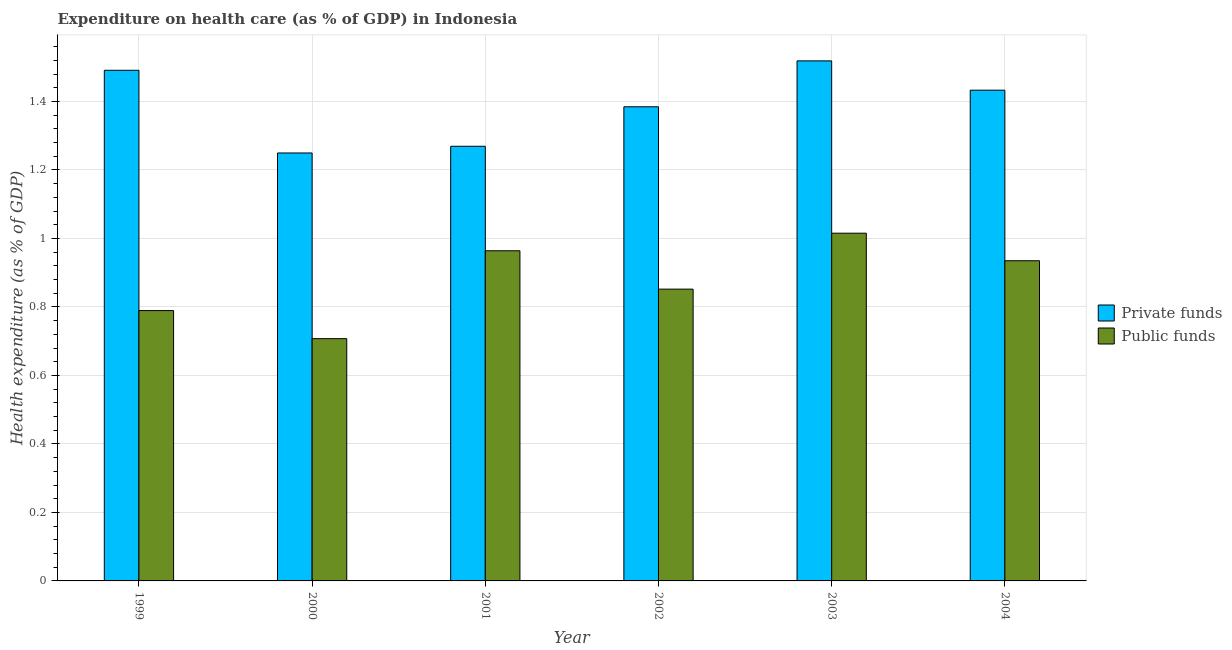How many different coloured bars are there?
Your response must be concise. 2. How many groups of bars are there?
Make the answer very short. 6. Are the number of bars per tick equal to the number of legend labels?
Make the answer very short. Yes. What is the label of the 6th group of bars from the left?
Provide a succinct answer. 2004. In how many cases, is the number of bars for a given year not equal to the number of legend labels?
Give a very brief answer. 0. What is the amount of public funds spent in healthcare in 2003?
Your answer should be compact. 1.02. Across all years, what is the maximum amount of private funds spent in healthcare?
Offer a very short reply. 1.52. Across all years, what is the minimum amount of public funds spent in healthcare?
Offer a terse response. 0.71. What is the total amount of public funds spent in healthcare in the graph?
Ensure brevity in your answer.  5.26. What is the difference between the amount of public funds spent in healthcare in 1999 and that in 2003?
Keep it short and to the point. -0.23. What is the difference between the amount of private funds spent in healthcare in 2001 and the amount of public funds spent in healthcare in 2004?
Make the answer very short. -0.16. What is the average amount of public funds spent in healthcare per year?
Give a very brief answer. 0.88. In the year 2001, what is the difference between the amount of private funds spent in healthcare and amount of public funds spent in healthcare?
Your answer should be very brief. 0. In how many years, is the amount of public funds spent in healthcare greater than 0.8 %?
Offer a very short reply. 4. What is the ratio of the amount of private funds spent in healthcare in 1999 to that in 2003?
Provide a short and direct response. 0.98. Is the amount of private funds spent in healthcare in 1999 less than that in 2003?
Keep it short and to the point. Yes. What is the difference between the highest and the second highest amount of public funds spent in healthcare?
Provide a succinct answer. 0.05. What is the difference between the highest and the lowest amount of public funds spent in healthcare?
Ensure brevity in your answer.  0.31. In how many years, is the amount of private funds spent in healthcare greater than the average amount of private funds spent in healthcare taken over all years?
Give a very brief answer. 3. Is the sum of the amount of public funds spent in healthcare in 1999 and 2001 greater than the maximum amount of private funds spent in healthcare across all years?
Your response must be concise. Yes. What does the 2nd bar from the left in 2002 represents?
Provide a short and direct response. Public funds. What does the 2nd bar from the right in 1999 represents?
Keep it short and to the point. Private funds. Are all the bars in the graph horizontal?
Keep it short and to the point. No. What is the difference between two consecutive major ticks on the Y-axis?
Offer a terse response. 0.2. Are the values on the major ticks of Y-axis written in scientific E-notation?
Your answer should be compact. No. Where does the legend appear in the graph?
Give a very brief answer. Center right. How many legend labels are there?
Provide a short and direct response. 2. How are the legend labels stacked?
Your answer should be compact. Vertical. What is the title of the graph?
Provide a short and direct response. Expenditure on health care (as % of GDP) in Indonesia. What is the label or title of the Y-axis?
Keep it short and to the point. Health expenditure (as % of GDP). What is the Health expenditure (as % of GDP) of Private funds in 1999?
Keep it short and to the point. 1.49. What is the Health expenditure (as % of GDP) of Public funds in 1999?
Offer a terse response. 0.79. What is the Health expenditure (as % of GDP) in Private funds in 2000?
Give a very brief answer. 1.25. What is the Health expenditure (as % of GDP) in Public funds in 2000?
Ensure brevity in your answer.  0.71. What is the Health expenditure (as % of GDP) in Private funds in 2001?
Provide a short and direct response. 1.27. What is the Health expenditure (as % of GDP) of Public funds in 2001?
Provide a short and direct response. 0.96. What is the Health expenditure (as % of GDP) of Private funds in 2002?
Your answer should be compact. 1.38. What is the Health expenditure (as % of GDP) in Public funds in 2002?
Ensure brevity in your answer.  0.85. What is the Health expenditure (as % of GDP) of Private funds in 2003?
Provide a short and direct response. 1.52. What is the Health expenditure (as % of GDP) of Public funds in 2003?
Offer a very short reply. 1.02. What is the Health expenditure (as % of GDP) in Private funds in 2004?
Your answer should be compact. 1.43. What is the Health expenditure (as % of GDP) in Public funds in 2004?
Your response must be concise. 0.93. Across all years, what is the maximum Health expenditure (as % of GDP) in Private funds?
Give a very brief answer. 1.52. Across all years, what is the maximum Health expenditure (as % of GDP) in Public funds?
Make the answer very short. 1.02. Across all years, what is the minimum Health expenditure (as % of GDP) of Private funds?
Keep it short and to the point. 1.25. Across all years, what is the minimum Health expenditure (as % of GDP) in Public funds?
Give a very brief answer. 0.71. What is the total Health expenditure (as % of GDP) in Private funds in the graph?
Keep it short and to the point. 8.35. What is the total Health expenditure (as % of GDP) of Public funds in the graph?
Your response must be concise. 5.26. What is the difference between the Health expenditure (as % of GDP) of Private funds in 1999 and that in 2000?
Provide a short and direct response. 0.24. What is the difference between the Health expenditure (as % of GDP) in Public funds in 1999 and that in 2000?
Your answer should be very brief. 0.08. What is the difference between the Health expenditure (as % of GDP) in Private funds in 1999 and that in 2001?
Give a very brief answer. 0.22. What is the difference between the Health expenditure (as % of GDP) of Public funds in 1999 and that in 2001?
Make the answer very short. -0.17. What is the difference between the Health expenditure (as % of GDP) in Private funds in 1999 and that in 2002?
Provide a succinct answer. 0.11. What is the difference between the Health expenditure (as % of GDP) in Public funds in 1999 and that in 2002?
Offer a very short reply. -0.06. What is the difference between the Health expenditure (as % of GDP) in Private funds in 1999 and that in 2003?
Your answer should be very brief. -0.03. What is the difference between the Health expenditure (as % of GDP) of Public funds in 1999 and that in 2003?
Offer a terse response. -0.23. What is the difference between the Health expenditure (as % of GDP) in Private funds in 1999 and that in 2004?
Provide a succinct answer. 0.06. What is the difference between the Health expenditure (as % of GDP) of Public funds in 1999 and that in 2004?
Give a very brief answer. -0.15. What is the difference between the Health expenditure (as % of GDP) in Private funds in 2000 and that in 2001?
Keep it short and to the point. -0.02. What is the difference between the Health expenditure (as % of GDP) in Public funds in 2000 and that in 2001?
Make the answer very short. -0.26. What is the difference between the Health expenditure (as % of GDP) in Private funds in 2000 and that in 2002?
Offer a very short reply. -0.13. What is the difference between the Health expenditure (as % of GDP) of Public funds in 2000 and that in 2002?
Ensure brevity in your answer.  -0.14. What is the difference between the Health expenditure (as % of GDP) in Private funds in 2000 and that in 2003?
Provide a succinct answer. -0.27. What is the difference between the Health expenditure (as % of GDP) of Public funds in 2000 and that in 2003?
Keep it short and to the point. -0.31. What is the difference between the Health expenditure (as % of GDP) in Private funds in 2000 and that in 2004?
Make the answer very short. -0.18. What is the difference between the Health expenditure (as % of GDP) in Public funds in 2000 and that in 2004?
Your response must be concise. -0.23. What is the difference between the Health expenditure (as % of GDP) in Private funds in 2001 and that in 2002?
Make the answer very short. -0.12. What is the difference between the Health expenditure (as % of GDP) of Public funds in 2001 and that in 2002?
Offer a very short reply. 0.11. What is the difference between the Health expenditure (as % of GDP) of Private funds in 2001 and that in 2003?
Provide a short and direct response. -0.25. What is the difference between the Health expenditure (as % of GDP) in Public funds in 2001 and that in 2003?
Ensure brevity in your answer.  -0.05. What is the difference between the Health expenditure (as % of GDP) in Private funds in 2001 and that in 2004?
Provide a succinct answer. -0.16. What is the difference between the Health expenditure (as % of GDP) of Public funds in 2001 and that in 2004?
Give a very brief answer. 0.03. What is the difference between the Health expenditure (as % of GDP) in Private funds in 2002 and that in 2003?
Provide a succinct answer. -0.13. What is the difference between the Health expenditure (as % of GDP) in Public funds in 2002 and that in 2003?
Ensure brevity in your answer.  -0.16. What is the difference between the Health expenditure (as % of GDP) in Private funds in 2002 and that in 2004?
Keep it short and to the point. -0.05. What is the difference between the Health expenditure (as % of GDP) of Public funds in 2002 and that in 2004?
Your answer should be compact. -0.08. What is the difference between the Health expenditure (as % of GDP) in Private funds in 2003 and that in 2004?
Provide a short and direct response. 0.09. What is the difference between the Health expenditure (as % of GDP) of Public funds in 2003 and that in 2004?
Make the answer very short. 0.08. What is the difference between the Health expenditure (as % of GDP) of Private funds in 1999 and the Health expenditure (as % of GDP) of Public funds in 2000?
Your answer should be compact. 0.78. What is the difference between the Health expenditure (as % of GDP) in Private funds in 1999 and the Health expenditure (as % of GDP) in Public funds in 2001?
Give a very brief answer. 0.53. What is the difference between the Health expenditure (as % of GDP) in Private funds in 1999 and the Health expenditure (as % of GDP) in Public funds in 2002?
Your answer should be compact. 0.64. What is the difference between the Health expenditure (as % of GDP) in Private funds in 1999 and the Health expenditure (as % of GDP) in Public funds in 2003?
Ensure brevity in your answer.  0.48. What is the difference between the Health expenditure (as % of GDP) in Private funds in 1999 and the Health expenditure (as % of GDP) in Public funds in 2004?
Offer a very short reply. 0.56. What is the difference between the Health expenditure (as % of GDP) of Private funds in 2000 and the Health expenditure (as % of GDP) of Public funds in 2001?
Make the answer very short. 0.29. What is the difference between the Health expenditure (as % of GDP) of Private funds in 2000 and the Health expenditure (as % of GDP) of Public funds in 2002?
Give a very brief answer. 0.4. What is the difference between the Health expenditure (as % of GDP) in Private funds in 2000 and the Health expenditure (as % of GDP) in Public funds in 2003?
Give a very brief answer. 0.23. What is the difference between the Health expenditure (as % of GDP) in Private funds in 2000 and the Health expenditure (as % of GDP) in Public funds in 2004?
Provide a short and direct response. 0.31. What is the difference between the Health expenditure (as % of GDP) of Private funds in 2001 and the Health expenditure (as % of GDP) of Public funds in 2002?
Your answer should be compact. 0.42. What is the difference between the Health expenditure (as % of GDP) in Private funds in 2001 and the Health expenditure (as % of GDP) in Public funds in 2003?
Your answer should be compact. 0.25. What is the difference between the Health expenditure (as % of GDP) of Private funds in 2001 and the Health expenditure (as % of GDP) of Public funds in 2004?
Ensure brevity in your answer.  0.33. What is the difference between the Health expenditure (as % of GDP) of Private funds in 2002 and the Health expenditure (as % of GDP) of Public funds in 2003?
Your answer should be compact. 0.37. What is the difference between the Health expenditure (as % of GDP) of Private funds in 2002 and the Health expenditure (as % of GDP) of Public funds in 2004?
Provide a succinct answer. 0.45. What is the difference between the Health expenditure (as % of GDP) of Private funds in 2003 and the Health expenditure (as % of GDP) of Public funds in 2004?
Offer a terse response. 0.58. What is the average Health expenditure (as % of GDP) in Private funds per year?
Provide a short and direct response. 1.39. What is the average Health expenditure (as % of GDP) in Public funds per year?
Give a very brief answer. 0.88. In the year 1999, what is the difference between the Health expenditure (as % of GDP) of Private funds and Health expenditure (as % of GDP) of Public funds?
Provide a short and direct response. 0.7. In the year 2000, what is the difference between the Health expenditure (as % of GDP) in Private funds and Health expenditure (as % of GDP) in Public funds?
Make the answer very short. 0.54. In the year 2001, what is the difference between the Health expenditure (as % of GDP) of Private funds and Health expenditure (as % of GDP) of Public funds?
Provide a short and direct response. 0.31. In the year 2002, what is the difference between the Health expenditure (as % of GDP) of Private funds and Health expenditure (as % of GDP) of Public funds?
Provide a succinct answer. 0.53. In the year 2003, what is the difference between the Health expenditure (as % of GDP) of Private funds and Health expenditure (as % of GDP) of Public funds?
Give a very brief answer. 0.5. In the year 2004, what is the difference between the Health expenditure (as % of GDP) in Private funds and Health expenditure (as % of GDP) in Public funds?
Give a very brief answer. 0.5. What is the ratio of the Health expenditure (as % of GDP) of Private funds in 1999 to that in 2000?
Offer a terse response. 1.19. What is the ratio of the Health expenditure (as % of GDP) of Public funds in 1999 to that in 2000?
Your answer should be compact. 1.12. What is the ratio of the Health expenditure (as % of GDP) in Private funds in 1999 to that in 2001?
Your response must be concise. 1.17. What is the ratio of the Health expenditure (as % of GDP) in Public funds in 1999 to that in 2001?
Make the answer very short. 0.82. What is the ratio of the Health expenditure (as % of GDP) in Private funds in 1999 to that in 2002?
Provide a succinct answer. 1.08. What is the ratio of the Health expenditure (as % of GDP) of Public funds in 1999 to that in 2002?
Your answer should be compact. 0.93. What is the ratio of the Health expenditure (as % of GDP) in Private funds in 1999 to that in 2003?
Your response must be concise. 0.98. What is the ratio of the Health expenditure (as % of GDP) of Public funds in 1999 to that in 2003?
Keep it short and to the point. 0.78. What is the ratio of the Health expenditure (as % of GDP) in Private funds in 1999 to that in 2004?
Provide a succinct answer. 1.04. What is the ratio of the Health expenditure (as % of GDP) in Public funds in 1999 to that in 2004?
Make the answer very short. 0.84. What is the ratio of the Health expenditure (as % of GDP) in Private funds in 2000 to that in 2001?
Provide a short and direct response. 0.98. What is the ratio of the Health expenditure (as % of GDP) of Public funds in 2000 to that in 2001?
Your answer should be very brief. 0.73. What is the ratio of the Health expenditure (as % of GDP) in Private funds in 2000 to that in 2002?
Make the answer very short. 0.9. What is the ratio of the Health expenditure (as % of GDP) in Public funds in 2000 to that in 2002?
Provide a short and direct response. 0.83. What is the ratio of the Health expenditure (as % of GDP) of Private funds in 2000 to that in 2003?
Ensure brevity in your answer.  0.82. What is the ratio of the Health expenditure (as % of GDP) of Public funds in 2000 to that in 2003?
Make the answer very short. 0.7. What is the ratio of the Health expenditure (as % of GDP) in Private funds in 2000 to that in 2004?
Ensure brevity in your answer.  0.87. What is the ratio of the Health expenditure (as % of GDP) of Public funds in 2000 to that in 2004?
Offer a terse response. 0.76. What is the ratio of the Health expenditure (as % of GDP) of Public funds in 2001 to that in 2002?
Make the answer very short. 1.13. What is the ratio of the Health expenditure (as % of GDP) of Private funds in 2001 to that in 2003?
Provide a short and direct response. 0.84. What is the ratio of the Health expenditure (as % of GDP) in Public funds in 2001 to that in 2003?
Make the answer very short. 0.95. What is the ratio of the Health expenditure (as % of GDP) of Private funds in 2001 to that in 2004?
Offer a very short reply. 0.89. What is the ratio of the Health expenditure (as % of GDP) of Public funds in 2001 to that in 2004?
Your response must be concise. 1.03. What is the ratio of the Health expenditure (as % of GDP) of Private funds in 2002 to that in 2003?
Provide a succinct answer. 0.91. What is the ratio of the Health expenditure (as % of GDP) in Public funds in 2002 to that in 2003?
Keep it short and to the point. 0.84. What is the ratio of the Health expenditure (as % of GDP) in Private funds in 2002 to that in 2004?
Ensure brevity in your answer.  0.97. What is the ratio of the Health expenditure (as % of GDP) of Public funds in 2002 to that in 2004?
Your answer should be compact. 0.91. What is the ratio of the Health expenditure (as % of GDP) in Private funds in 2003 to that in 2004?
Your answer should be very brief. 1.06. What is the ratio of the Health expenditure (as % of GDP) of Public funds in 2003 to that in 2004?
Your response must be concise. 1.09. What is the difference between the highest and the second highest Health expenditure (as % of GDP) in Private funds?
Your response must be concise. 0.03. What is the difference between the highest and the second highest Health expenditure (as % of GDP) in Public funds?
Offer a very short reply. 0.05. What is the difference between the highest and the lowest Health expenditure (as % of GDP) in Private funds?
Your answer should be very brief. 0.27. What is the difference between the highest and the lowest Health expenditure (as % of GDP) in Public funds?
Provide a short and direct response. 0.31. 